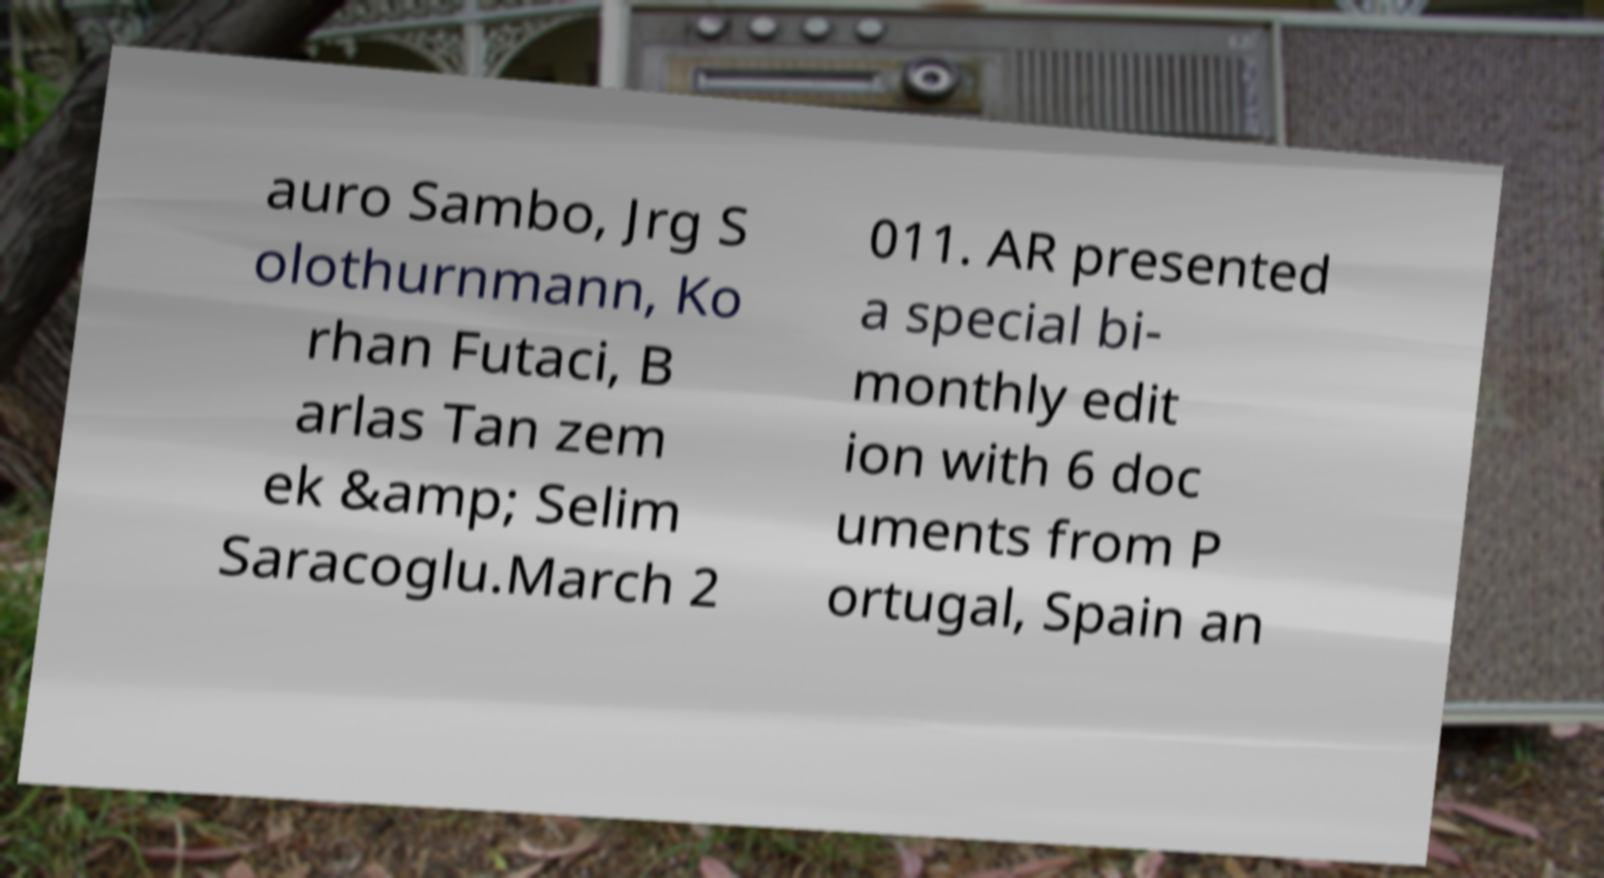For documentation purposes, I need the text within this image transcribed. Could you provide that? auro Sambo, Jrg S olothurnmann, Ko rhan Futaci, B arlas Tan zem ek &amp; Selim Saracoglu.March 2 011. AR presented a special bi- monthly edit ion with 6 doc uments from P ortugal, Spain an 